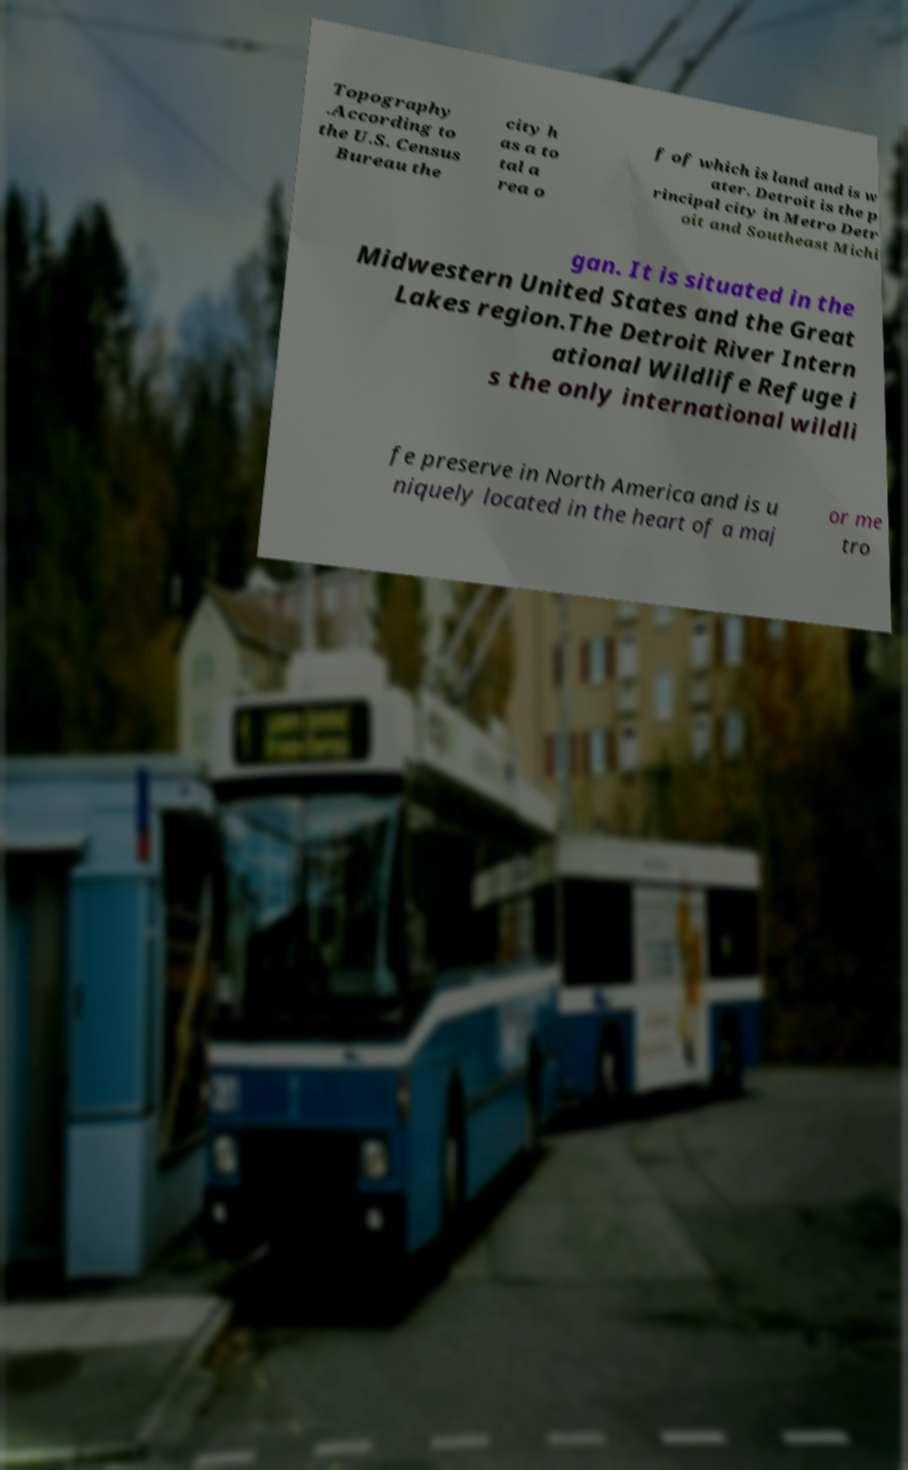Please identify and transcribe the text found in this image. Topography .According to the U.S. Census Bureau the city h as a to tal a rea o f of which is land and is w ater. Detroit is the p rincipal city in Metro Detr oit and Southeast Michi gan. It is situated in the Midwestern United States and the Great Lakes region.The Detroit River Intern ational Wildlife Refuge i s the only international wildli fe preserve in North America and is u niquely located in the heart of a maj or me tro 